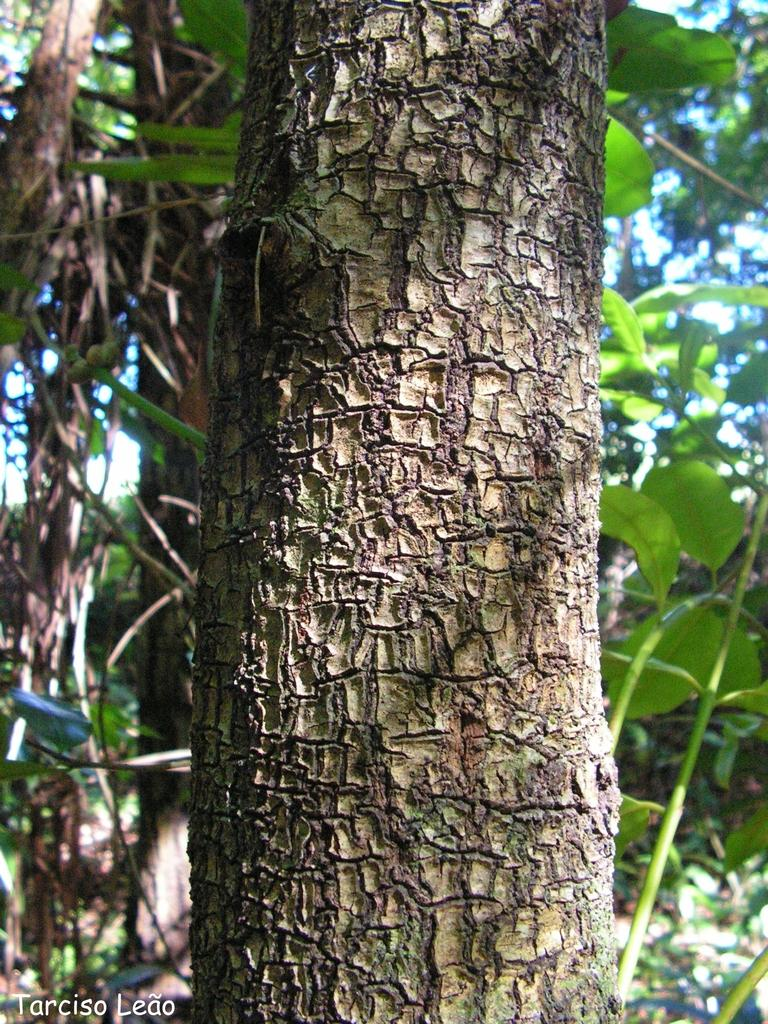What is the main subject of the image? The main subject of the image is a close-up of a bark. Is there any text present in the image? Yes, there is text in the bottom left corner of the image. What can be seen in the background of the image? In the background of the image, there are leaves and trees. How many toothpaste tubes can be seen in the image? There are no toothpaste tubes present in the image; it is a close-up of a bark with leaves and trees in the background. What type of pies are being served in the image? There are no pies present in the image; it is a close-up of a bark with leaves and trees in the background. 